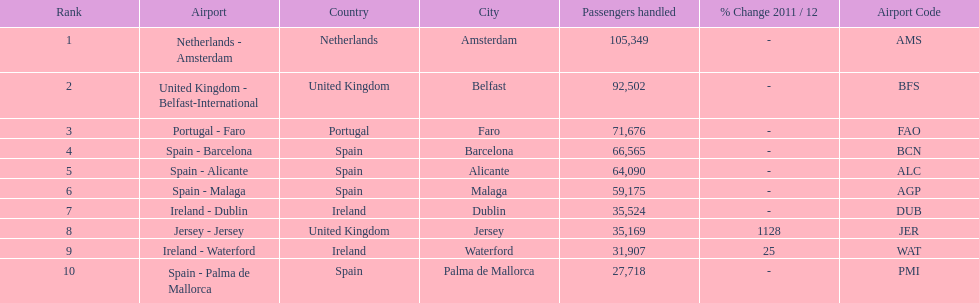Which airport has no more than 30,000 passengers handled among the 10 busiest routes to and from london southend airport in 2012? Spain - Palma de Mallorca. 